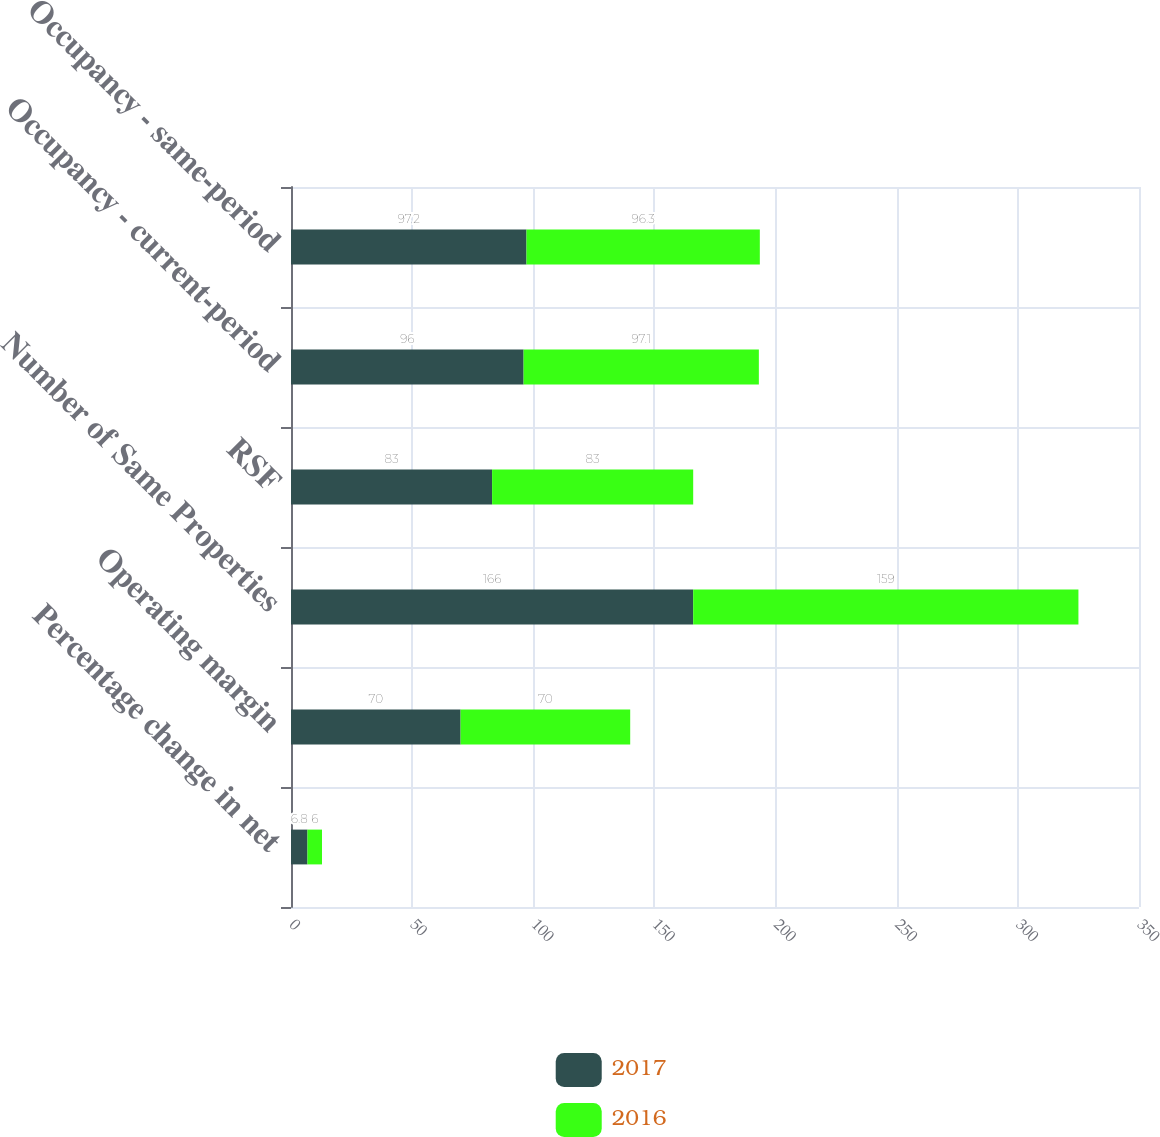Convert chart. <chart><loc_0><loc_0><loc_500><loc_500><stacked_bar_chart><ecel><fcel>Percentage change in net<fcel>Operating margin<fcel>Number of Same Properties<fcel>RSF<fcel>Occupancy - current-period<fcel>Occupancy - same-period<nl><fcel>2017<fcel>6.8<fcel>70<fcel>166<fcel>83<fcel>96<fcel>97.2<nl><fcel>2016<fcel>6<fcel>70<fcel>159<fcel>83<fcel>97.1<fcel>96.3<nl></chart> 